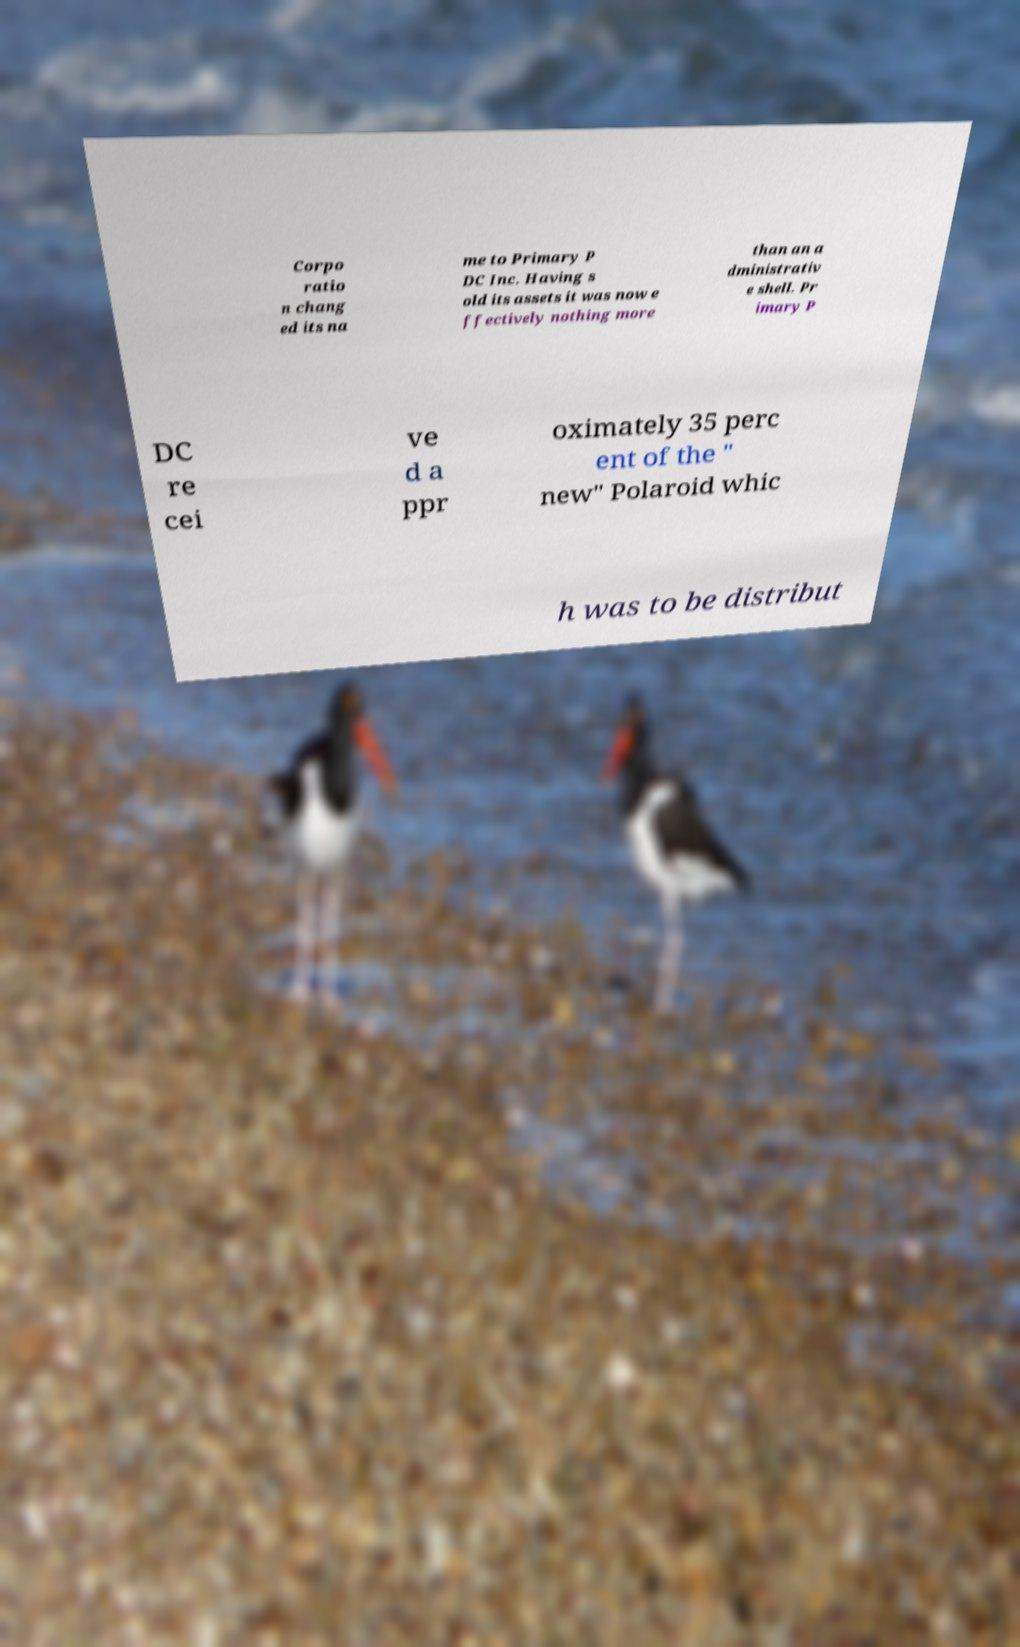Could you extract and type out the text from this image? Corpo ratio n chang ed its na me to Primary P DC Inc. Having s old its assets it was now e ffectively nothing more than an a dministrativ e shell. Pr imary P DC re cei ve d a ppr oximately 35 perc ent of the " new" Polaroid whic h was to be distribut 